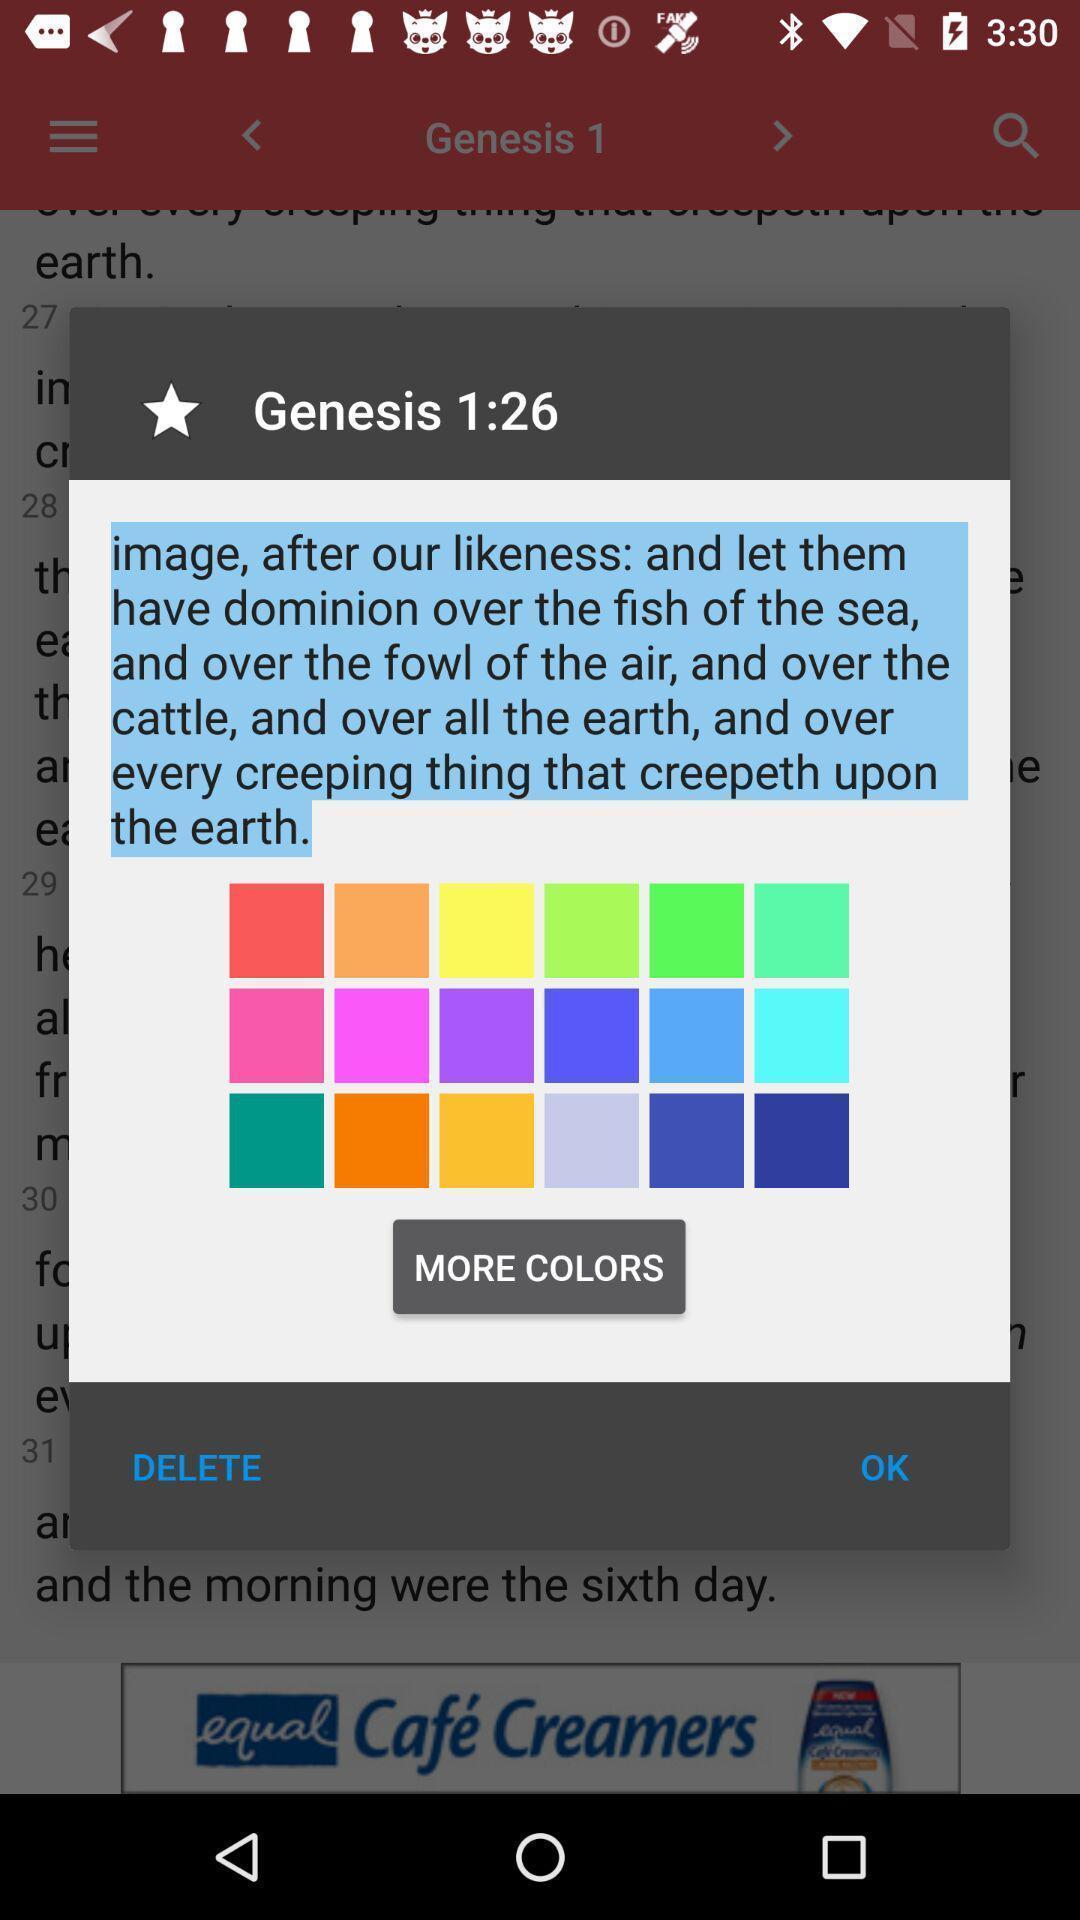Provide a textual representation of this image. Pop up showing multiple colour options. 